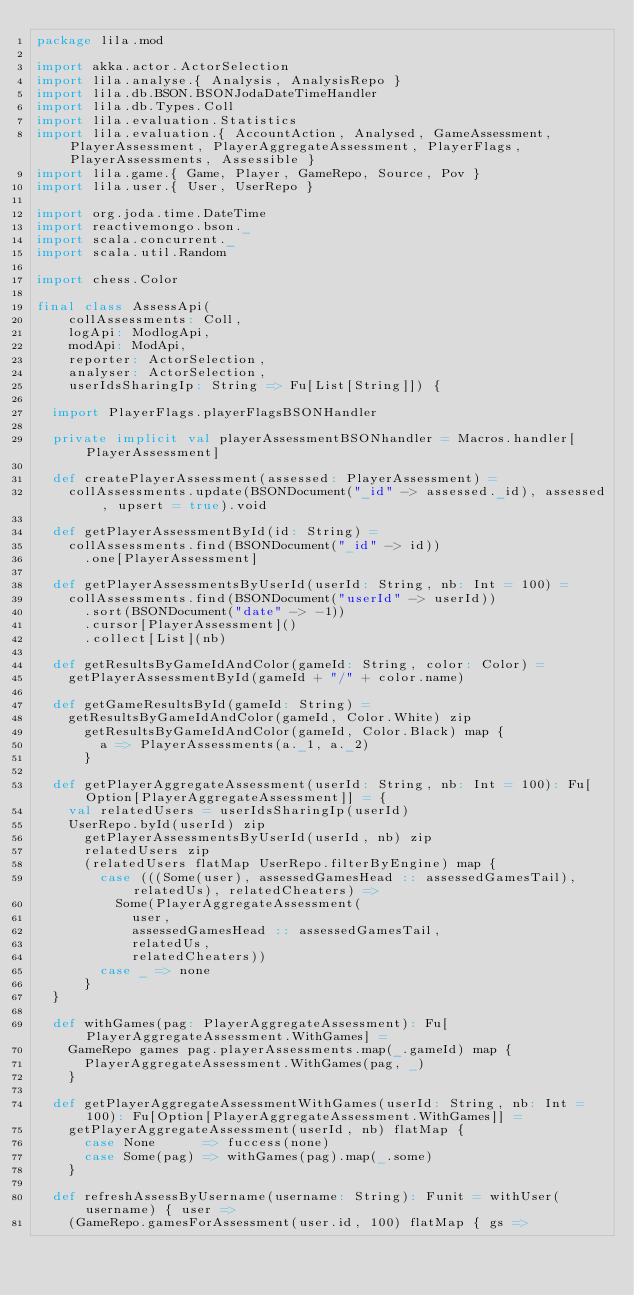<code> <loc_0><loc_0><loc_500><loc_500><_Scala_>package lila.mod

import akka.actor.ActorSelection
import lila.analyse.{ Analysis, AnalysisRepo }
import lila.db.BSON.BSONJodaDateTimeHandler
import lila.db.Types.Coll
import lila.evaluation.Statistics
import lila.evaluation.{ AccountAction, Analysed, GameAssessment, PlayerAssessment, PlayerAggregateAssessment, PlayerFlags, PlayerAssessments, Assessible }
import lila.game.{ Game, Player, GameRepo, Source, Pov }
import lila.user.{ User, UserRepo }

import org.joda.time.DateTime
import reactivemongo.bson._
import scala.concurrent._
import scala.util.Random

import chess.Color

final class AssessApi(
    collAssessments: Coll,
    logApi: ModlogApi,
    modApi: ModApi,
    reporter: ActorSelection,
    analyser: ActorSelection,
    userIdsSharingIp: String => Fu[List[String]]) {

  import PlayerFlags.playerFlagsBSONHandler

  private implicit val playerAssessmentBSONhandler = Macros.handler[PlayerAssessment]

  def createPlayerAssessment(assessed: PlayerAssessment) =
    collAssessments.update(BSONDocument("_id" -> assessed._id), assessed, upsert = true).void

  def getPlayerAssessmentById(id: String) =
    collAssessments.find(BSONDocument("_id" -> id))
      .one[PlayerAssessment]

  def getPlayerAssessmentsByUserId(userId: String, nb: Int = 100) =
    collAssessments.find(BSONDocument("userId" -> userId))
      .sort(BSONDocument("date" -> -1))
      .cursor[PlayerAssessment]()
      .collect[List](nb)

  def getResultsByGameIdAndColor(gameId: String, color: Color) =
    getPlayerAssessmentById(gameId + "/" + color.name)

  def getGameResultsById(gameId: String) =
    getResultsByGameIdAndColor(gameId, Color.White) zip
      getResultsByGameIdAndColor(gameId, Color.Black) map {
        a => PlayerAssessments(a._1, a._2)
      }

  def getPlayerAggregateAssessment(userId: String, nb: Int = 100): Fu[Option[PlayerAggregateAssessment]] = {
    val relatedUsers = userIdsSharingIp(userId)
    UserRepo.byId(userId) zip
      getPlayerAssessmentsByUserId(userId, nb) zip
      relatedUsers zip
      (relatedUsers flatMap UserRepo.filterByEngine) map {
        case (((Some(user), assessedGamesHead :: assessedGamesTail), relatedUs), relatedCheaters) =>
          Some(PlayerAggregateAssessment(
            user,
            assessedGamesHead :: assessedGamesTail,
            relatedUs,
            relatedCheaters))
        case _ => none
      }
  }

  def withGames(pag: PlayerAggregateAssessment): Fu[PlayerAggregateAssessment.WithGames] =
    GameRepo games pag.playerAssessments.map(_.gameId) map {
      PlayerAggregateAssessment.WithGames(pag, _)
    }

  def getPlayerAggregateAssessmentWithGames(userId: String, nb: Int = 100): Fu[Option[PlayerAggregateAssessment.WithGames]] =
    getPlayerAggregateAssessment(userId, nb) flatMap {
      case None      => fuccess(none)
      case Some(pag) => withGames(pag).map(_.some)
    }

  def refreshAssessByUsername(username: String): Funit = withUser(username) { user =>
    (GameRepo.gamesForAssessment(user.id, 100) flatMap { gs =></code> 